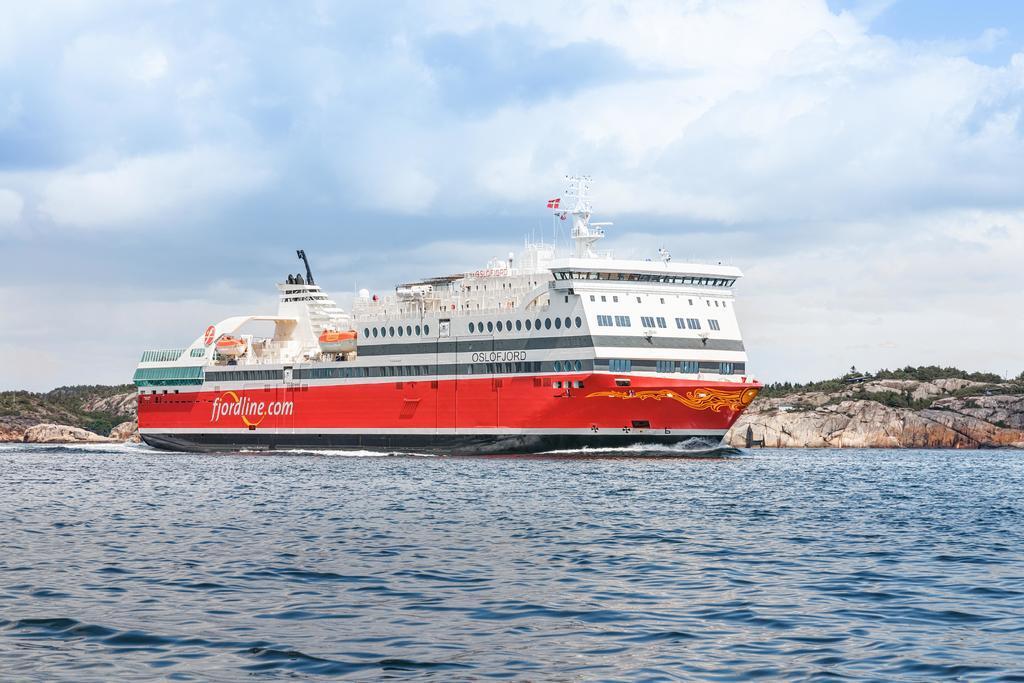Please provide a concise description of this image. In this image I can see a ship on the water. There are mountains at the back and sky at the top. 